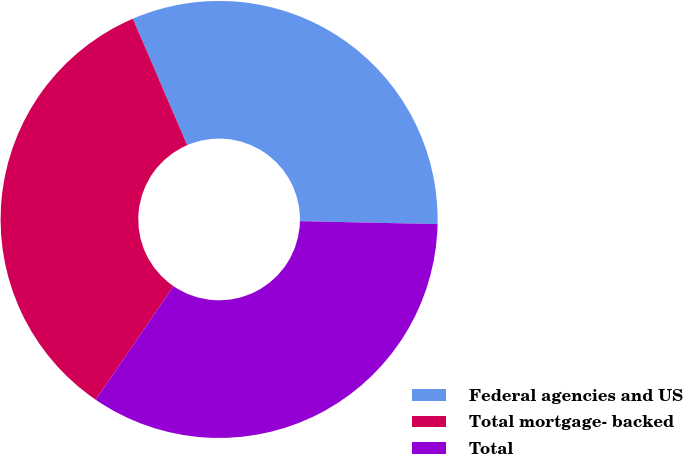Convert chart. <chart><loc_0><loc_0><loc_500><loc_500><pie_chart><fcel>Federal agencies and US<fcel>Total mortgage- backed<fcel>Total<nl><fcel>31.8%<fcel>33.99%<fcel>34.22%<nl></chart> 